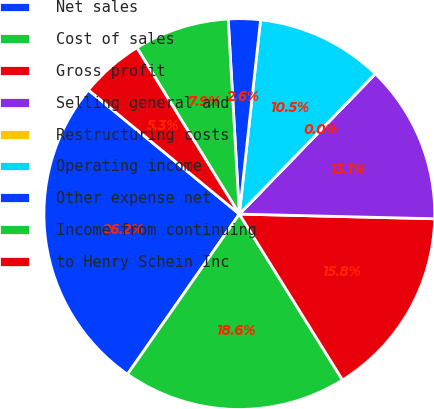Convert chart to OTSL. <chart><loc_0><loc_0><loc_500><loc_500><pie_chart><fcel>Net sales<fcel>Cost of sales<fcel>Gross profit<fcel>Selling general and<fcel>Restructuring costs<fcel>Operating income<fcel>Other expense net<fcel>Income from continuing<fcel>to Henry Schein Inc<nl><fcel>26.25%<fcel>18.56%<fcel>15.76%<fcel>13.13%<fcel>0.01%<fcel>10.51%<fcel>2.64%<fcel>7.88%<fcel>5.26%<nl></chart> 